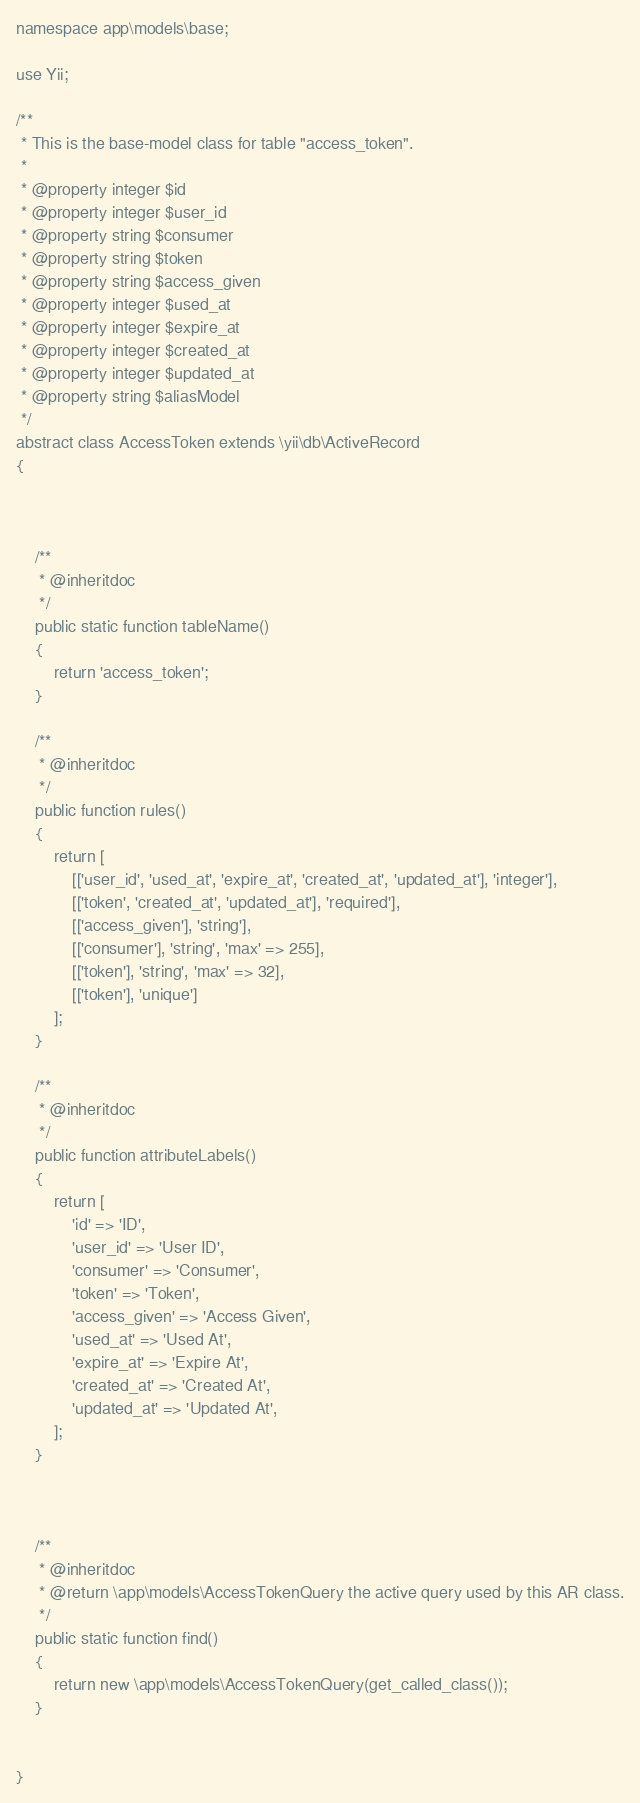Convert code to text. <code><loc_0><loc_0><loc_500><loc_500><_PHP_>
namespace app\models\base;

use Yii;

/**
 * This is the base-model class for table "access_token".
 *
 * @property integer $id
 * @property integer $user_id
 * @property string $consumer
 * @property string $token
 * @property string $access_given
 * @property integer $used_at
 * @property integer $expire_at
 * @property integer $created_at
 * @property integer $updated_at
 * @property string $aliasModel
 */
abstract class AccessToken extends \yii\db\ActiveRecord
{



    /**
     * @inheritdoc
     */
    public static function tableName()
    {
        return 'access_token';
    }

    /**
     * @inheritdoc
     */
    public function rules()
    {
        return [
            [['user_id', 'used_at', 'expire_at', 'created_at', 'updated_at'], 'integer'],
            [['token', 'created_at', 'updated_at'], 'required'],
            [['access_given'], 'string'],
            [['consumer'], 'string', 'max' => 255],
            [['token'], 'string', 'max' => 32],
            [['token'], 'unique']
        ];
    }

    /**
     * @inheritdoc
     */
    public function attributeLabels()
    {
        return [
            'id' => 'ID',
            'user_id' => 'User ID',
            'consumer' => 'Consumer',
            'token' => 'Token',
            'access_given' => 'Access Given',
            'used_at' => 'Used At',
            'expire_at' => 'Expire At',
            'created_at' => 'Created At',
            'updated_at' => 'Updated At',
        ];
    }


    
    /**
     * @inheritdoc
     * @return \app\models\AccessTokenQuery the active query used by this AR class.
     */
    public static function find()
    {
        return new \app\models\AccessTokenQuery(get_called_class());
    }


}
</code> 